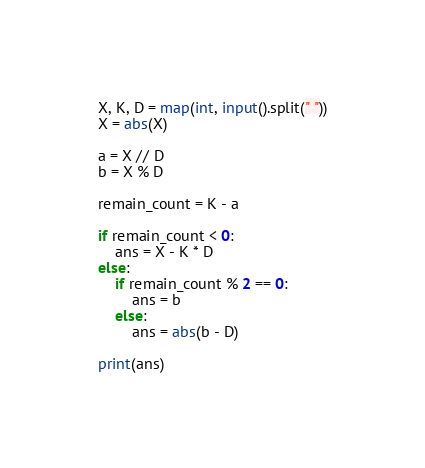Convert code to text. <code><loc_0><loc_0><loc_500><loc_500><_Python_>X, K, D = map(int, input().split(" "))
X = abs(X)
 
a = X // D
b = X % D
 
remain_count = K - a
 
if remain_count < 0:
    ans = X - K * D
else:
    if remain_count % 2 == 0:
        ans = b
    else:
        ans = abs(b - D)
    
print(ans)</code> 